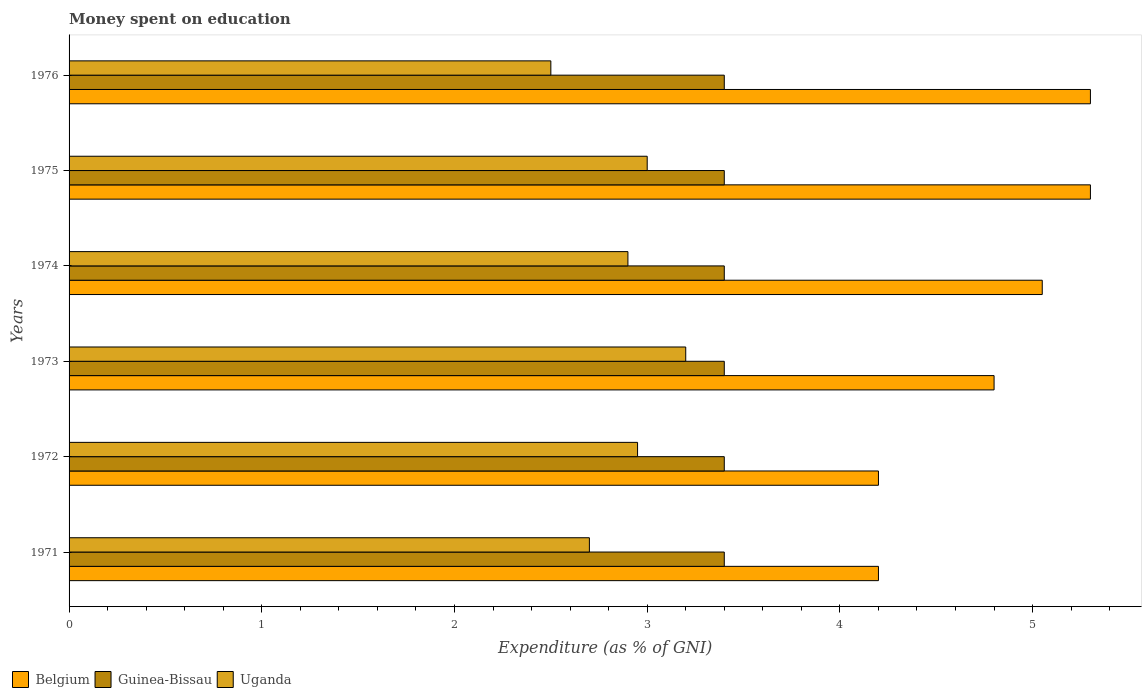How many groups of bars are there?
Your answer should be very brief. 6. Are the number of bars on each tick of the Y-axis equal?
Your response must be concise. Yes. How many bars are there on the 6th tick from the bottom?
Ensure brevity in your answer.  3. What is the label of the 6th group of bars from the top?
Give a very brief answer. 1971. What is the amount of money spent on education in Uganda in 1974?
Your answer should be very brief. 2.9. In which year was the amount of money spent on education in Uganda maximum?
Give a very brief answer. 1973. What is the total amount of money spent on education in Guinea-Bissau in the graph?
Offer a terse response. 20.4. What is the difference between the amount of money spent on education in Belgium in 1971 and that in 1973?
Make the answer very short. -0.6. What is the difference between the amount of money spent on education in Belgium in 1971 and the amount of money spent on education in Uganda in 1973?
Ensure brevity in your answer.  1. What is the average amount of money spent on education in Belgium per year?
Your answer should be very brief. 4.81. In the year 1974, what is the difference between the amount of money spent on education in Guinea-Bissau and amount of money spent on education in Belgium?
Offer a very short reply. -1.65. In how many years, is the amount of money spent on education in Guinea-Bissau greater than 3 %?
Keep it short and to the point. 6. Is the difference between the amount of money spent on education in Guinea-Bissau in 1972 and 1975 greater than the difference between the amount of money spent on education in Belgium in 1972 and 1975?
Offer a very short reply. Yes. What is the difference between the highest and the lowest amount of money spent on education in Belgium?
Ensure brevity in your answer.  1.1. In how many years, is the amount of money spent on education in Guinea-Bissau greater than the average amount of money spent on education in Guinea-Bissau taken over all years?
Keep it short and to the point. 0. Is the sum of the amount of money spent on education in Guinea-Bissau in 1974 and 1975 greater than the maximum amount of money spent on education in Uganda across all years?
Give a very brief answer. Yes. What does the 1st bar from the top in 1976 represents?
Your response must be concise. Uganda. What does the 1st bar from the bottom in 1972 represents?
Your answer should be very brief. Belgium. Are all the bars in the graph horizontal?
Make the answer very short. Yes. What is the difference between two consecutive major ticks on the X-axis?
Provide a succinct answer. 1. Are the values on the major ticks of X-axis written in scientific E-notation?
Your response must be concise. No. How are the legend labels stacked?
Offer a very short reply. Horizontal. What is the title of the graph?
Ensure brevity in your answer.  Money spent on education. What is the label or title of the X-axis?
Provide a succinct answer. Expenditure (as % of GNI). What is the label or title of the Y-axis?
Provide a short and direct response. Years. What is the Expenditure (as % of GNI) of Guinea-Bissau in 1971?
Give a very brief answer. 3.4. What is the Expenditure (as % of GNI) in Belgium in 1972?
Offer a terse response. 4.2. What is the Expenditure (as % of GNI) in Uganda in 1972?
Your response must be concise. 2.95. What is the Expenditure (as % of GNI) in Belgium in 1973?
Make the answer very short. 4.8. What is the Expenditure (as % of GNI) of Uganda in 1973?
Your answer should be very brief. 3.2. What is the Expenditure (as % of GNI) in Belgium in 1974?
Your response must be concise. 5.05. What is the Expenditure (as % of GNI) of Guinea-Bissau in 1974?
Offer a terse response. 3.4. What is the Expenditure (as % of GNI) in Guinea-Bissau in 1975?
Give a very brief answer. 3.4. What is the Expenditure (as % of GNI) of Guinea-Bissau in 1976?
Provide a succinct answer. 3.4. What is the Expenditure (as % of GNI) of Uganda in 1976?
Keep it short and to the point. 2.5. Across all years, what is the maximum Expenditure (as % of GNI) in Belgium?
Ensure brevity in your answer.  5.3. Across all years, what is the minimum Expenditure (as % of GNI) in Uganda?
Provide a succinct answer. 2.5. What is the total Expenditure (as % of GNI) of Belgium in the graph?
Provide a succinct answer. 28.85. What is the total Expenditure (as % of GNI) of Guinea-Bissau in the graph?
Ensure brevity in your answer.  20.4. What is the total Expenditure (as % of GNI) of Uganda in the graph?
Provide a short and direct response. 17.25. What is the difference between the Expenditure (as % of GNI) in Uganda in 1971 and that in 1972?
Make the answer very short. -0.25. What is the difference between the Expenditure (as % of GNI) of Belgium in 1971 and that in 1973?
Provide a short and direct response. -0.6. What is the difference between the Expenditure (as % of GNI) in Belgium in 1971 and that in 1974?
Give a very brief answer. -0.85. What is the difference between the Expenditure (as % of GNI) of Guinea-Bissau in 1971 and that in 1974?
Provide a short and direct response. 0. What is the difference between the Expenditure (as % of GNI) in Belgium in 1971 and that in 1975?
Provide a succinct answer. -1.1. What is the difference between the Expenditure (as % of GNI) of Guinea-Bissau in 1971 and that in 1976?
Offer a very short reply. 0. What is the difference between the Expenditure (as % of GNI) in Uganda in 1971 and that in 1976?
Give a very brief answer. 0.2. What is the difference between the Expenditure (as % of GNI) of Belgium in 1972 and that in 1973?
Keep it short and to the point. -0.6. What is the difference between the Expenditure (as % of GNI) in Uganda in 1972 and that in 1973?
Your answer should be compact. -0.25. What is the difference between the Expenditure (as % of GNI) of Belgium in 1972 and that in 1974?
Make the answer very short. -0.85. What is the difference between the Expenditure (as % of GNI) of Uganda in 1972 and that in 1974?
Provide a short and direct response. 0.05. What is the difference between the Expenditure (as % of GNI) in Belgium in 1972 and that in 1975?
Ensure brevity in your answer.  -1.1. What is the difference between the Expenditure (as % of GNI) of Guinea-Bissau in 1972 and that in 1975?
Offer a terse response. 0. What is the difference between the Expenditure (as % of GNI) in Uganda in 1972 and that in 1975?
Offer a very short reply. -0.05. What is the difference between the Expenditure (as % of GNI) of Guinea-Bissau in 1972 and that in 1976?
Provide a short and direct response. 0. What is the difference between the Expenditure (as % of GNI) of Uganda in 1972 and that in 1976?
Your answer should be very brief. 0.45. What is the difference between the Expenditure (as % of GNI) of Belgium in 1973 and that in 1974?
Provide a short and direct response. -0.25. What is the difference between the Expenditure (as % of GNI) of Uganda in 1973 and that in 1974?
Your answer should be compact. 0.3. What is the difference between the Expenditure (as % of GNI) of Belgium in 1973 and that in 1975?
Your answer should be compact. -0.5. What is the difference between the Expenditure (as % of GNI) of Uganda in 1973 and that in 1975?
Give a very brief answer. 0.2. What is the difference between the Expenditure (as % of GNI) in Guinea-Bissau in 1974 and that in 1975?
Provide a short and direct response. 0. What is the difference between the Expenditure (as % of GNI) of Uganda in 1974 and that in 1975?
Ensure brevity in your answer.  -0.1. What is the difference between the Expenditure (as % of GNI) of Belgium in 1974 and that in 1976?
Ensure brevity in your answer.  -0.25. What is the difference between the Expenditure (as % of GNI) of Guinea-Bissau in 1974 and that in 1976?
Your answer should be compact. 0. What is the difference between the Expenditure (as % of GNI) in Belgium in 1971 and the Expenditure (as % of GNI) in Guinea-Bissau in 1972?
Ensure brevity in your answer.  0.8. What is the difference between the Expenditure (as % of GNI) of Belgium in 1971 and the Expenditure (as % of GNI) of Uganda in 1972?
Provide a succinct answer. 1.25. What is the difference between the Expenditure (as % of GNI) in Guinea-Bissau in 1971 and the Expenditure (as % of GNI) in Uganda in 1972?
Your response must be concise. 0.45. What is the difference between the Expenditure (as % of GNI) of Belgium in 1971 and the Expenditure (as % of GNI) of Guinea-Bissau in 1973?
Ensure brevity in your answer.  0.8. What is the difference between the Expenditure (as % of GNI) of Belgium in 1971 and the Expenditure (as % of GNI) of Guinea-Bissau in 1974?
Your answer should be compact. 0.8. What is the difference between the Expenditure (as % of GNI) of Belgium in 1971 and the Expenditure (as % of GNI) of Uganda in 1974?
Provide a short and direct response. 1.3. What is the difference between the Expenditure (as % of GNI) of Belgium in 1971 and the Expenditure (as % of GNI) of Guinea-Bissau in 1975?
Make the answer very short. 0.8. What is the difference between the Expenditure (as % of GNI) in Belgium in 1971 and the Expenditure (as % of GNI) in Uganda in 1975?
Offer a very short reply. 1.2. What is the difference between the Expenditure (as % of GNI) of Belgium in 1971 and the Expenditure (as % of GNI) of Guinea-Bissau in 1976?
Your answer should be very brief. 0.8. What is the difference between the Expenditure (as % of GNI) in Belgium in 1972 and the Expenditure (as % of GNI) in Guinea-Bissau in 1973?
Give a very brief answer. 0.8. What is the difference between the Expenditure (as % of GNI) of Guinea-Bissau in 1972 and the Expenditure (as % of GNI) of Uganda in 1973?
Offer a very short reply. 0.2. What is the difference between the Expenditure (as % of GNI) of Guinea-Bissau in 1972 and the Expenditure (as % of GNI) of Uganda in 1974?
Ensure brevity in your answer.  0.5. What is the difference between the Expenditure (as % of GNI) in Belgium in 1972 and the Expenditure (as % of GNI) in Guinea-Bissau in 1975?
Offer a terse response. 0.8. What is the difference between the Expenditure (as % of GNI) in Belgium in 1972 and the Expenditure (as % of GNI) in Uganda in 1975?
Your answer should be very brief. 1.2. What is the difference between the Expenditure (as % of GNI) in Guinea-Bissau in 1972 and the Expenditure (as % of GNI) in Uganda in 1975?
Offer a very short reply. 0.4. What is the difference between the Expenditure (as % of GNI) in Belgium in 1972 and the Expenditure (as % of GNI) in Guinea-Bissau in 1976?
Offer a very short reply. 0.8. What is the difference between the Expenditure (as % of GNI) in Belgium in 1973 and the Expenditure (as % of GNI) in Guinea-Bissau in 1974?
Your answer should be very brief. 1.4. What is the difference between the Expenditure (as % of GNI) of Belgium in 1973 and the Expenditure (as % of GNI) of Guinea-Bissau in 1975?
Offer a very short reply. 1.4. What is the difference between the Expenditure (as % of GNI) of Guinea-Bissau in 1973 and the Expenditure (as % of GNI) of Uganda in 1975?
Provide a succinct answer. 0.4. What is the difference between the Expenditure (as % of GNI) of Guinea-Bissau in 1973 and the Expenditure (as % of GNI) of Uganda in 1976?
Ensure brevity in your answer.  0.9. What is the difference between the Expenditure (as % of GNI) in Belgium in 1974 and the Expenditure (as % of GNI) in Guinea-Bissau in 1975?
Give a very brief answer. 1.65. What is the difference between the Expenditure (as % of GNI) in Belgium in 1974 and the Expenditure (as % of GNI) in Uganda in 1975?
Offer a terse response. 2.05. What is the difference between the Expenditure (as % of GNI) of Belgium in 1974 and the Expenditure (as % of GNI) of Guinea-Bissau in 1976?
Your response must be concise. 1.65. What is the difference between the Expenditure (as % of GNI) of Belgium in 1974 and the Expenditure (as % of GNI) of Uganda in 1976?
Your answer should be compact. 2.55. What is the difference between the Expenditure (as % of GNI) in Guinea-Bissau in 1975 and the Expenditure (as % of GNI) in Uganda in 1976?
Provide a succinct answer. 0.9. What is the average Expenditure (as % of GNI) of Belgium per year?
Offer a very short reply. 4.81. What is the average Expenditure (as % of GNI) of Guinea-Bissau per year?
Give a very brief answer. 3.4. What is the average Expenditure (as % of GNI) in Uganda per year?
Keep it short and to the point. 2.88. In the year 1972, what is the difference between the Expenditure (as % of GNI) in Belgium and Expenditure (as % of GNI) in Guinea-Bissau?
Your answer should be very brief. 0.8. In the year 1972, what is the difference between the Expenditure (as % of GNI) in Belgium and Expenditure (as % of GNI) in Uganda?
Keep it short and to the point. 1.25. In the year 1972, what is the difference between the Expenditure (as % of GNI) in Guinea-Bissau and Expenditure (as % of GNI) in Uganda?
Make the answer very short. 0.45. In the year 1974, what is the difference between the Expenditure (as % of GNI) of Belgium and Expenditure (as % of GNI) of Guinea-Bissau?
Give a very brief answer. 1.65. In the year 1974, what is the difference between the Expenditure (as % of GNI) of Belgium and Expenditure (as % of GNI) of Uganda?
Offer a very short reply. 2.15. In the year 1974, what is the difference between the Expenditure (as % of GNI) in Guinea-Bissau and Expenditure (as % of GNI) in Uganda?
Offer a terse response. 0.5. In the year 1975, what is the difference between the Expenditure (as % of GNI) of Guinea-Bissau and Expenditure (as % of GNI) of Uganda?
Your answer should be very brief. 0.4. What is the ratio of the Expenditure (as % of GNI) in Belgium in 1971 to that in 1972?
Provide a short and direct response. 1. What is the ratio of the Expenditure (as % of GNI) of Guinea-Bissau in 1971 to that in 1972?
Offer a very short reply. 1. What is the ratio of the Expenditure (as % of GNI) in Uganda in 1971 to that in 1972?
Ensure brevity in your answer.  0.92. What is the ratio of the Expenditure (as % of GNI) in Belgium in 1971 to that in 1973?
Make the answer very short. 0.88. What is the ratio of the Expenditure (as % of GNI) of Guinea-Bissau in 1971 to that in 1973?
Offer a terse response. 1. What is the ratio of the Expenditure (as % of GNI) of Uganda in 1971 to that in 1973?
Ensure brevity in your answer.  0.84. What is the ratio of the Expenditure (as % of GNI) in Belgium in 1971 to that in 1974?
Your answer should be compact. 0.83. What is the ratio of the Expenditure (as % of GNI) of Guinea-Bissau in 1971 to that in 1974?
Your answer should be compact. 1. What is the ratio of the Expenditure (as % of GNI) in Belgium in 1971 to that in 1975?
Your response must be concise. 0.79. What is the ratio of the Expenditure (as % of GNI) of Uganda in 1971 to that in 1975?
Your response must be concise. 0.9. What is the ratio of the Expenditure (as % of GNI) in Belgium in 1971 to that in 1976?
Give a very brief answer. 0.79. What is the ratio of the Expenditure (as % of GNI) of Guinea-Bissau in 1971 to that in 1976?
Your response must be concise. 1. What is the ratio of the Expenditure (as % of GNI) of Uganda in 1971 to that in 1976?
Provide a succinct answer. 1.08. What is the ratio of the Expenditure (as % of GNI) of Belgium in 1972 to that in 1973?
Provide a succinct answer. 0.88. What is the ratio of the Expenditure (as % of GNI) in Guinea-Bissau in 1972 to that in 1973?
Keep it short and to the point. 1. What is the ratio of the Expenditure (as % of GNI) of Uganda in 1972 to that in 1973?
Ensure brevity in your answer.  0.92. What is the ratio of the Expenditure (as % of GNI) of Belgium in 1972 to that in 1974?
Your answer should be compact. 0.83. What is the ratio of the Expenditure (as % of GNI) in Uganda in 1972 to that in 1974?
Provide a short and direct response. 1.02. What is the ratio of the Expenditure (as % of GNI) of Belgium in 1972 to that in 1975?
Ensure brevity in your answer.  0.79. What is the ratio of the Expenditure (as % of GNI) in Uganda in 1972 to that in 1975?
Keep it short and to the point. 0.98. What is the ratio of the Expenditure (as % of GNI) in Belgium in 1972 to that in 1976?
Give a very brief answer. 0.79. What is the ratio of the Expenditure (as % of GNI) in Guinea-Bissau in 1972 to that in 1976?
Offer a terse response. 1. What is the ratio of the Expenditure (as % of GNI) of Uganda in 1972 to that in 1976?
Provide a short and direct response. 1.18. What is the ratio of the Expenditure (as % of GNI) in Belgium in 1973 to that in 1974?
Offer a terse response. 0.95. What is the ratio of the Expenditure (as % of GNI) of Uganda in 1973 to that in 1974?
Provide a succinct answer. 1.1. What is the ratio of the Expenditure (as % of GNI) of Belgium in 1973 to that in 1975?
Offer a very short reply. 0.91. What is the ratio of the Expenditure (as % of GNI) of Guinea-Bissau in 1973 to that in 1975?
Ensure brevity in your answer.  1. What is the ratio of the Expenditure (as % of GNI) in Uganda in 1973 to that in 1975?
Ensure brevity in your answer.  1.07. What is the ratio of the Expenditure (as % of GNI) of Belgium in 1973 to that in 1976?
Your answer should be compact. 0.91. What is the ratio of the Expenditure (as % of GNI) in Guinea-Bissau in 1973 to that in 1976?
Offer a very short reply. 1. What is the ratio of the Expenditure (as % of GNI) in Uganda in 1973 to that in 1976?
Offer a terse response. 1.28. What is the ratio of the Expenditure (as % of GNI) of Belgium in 1974 to that in 1975?
Provide a succinct answer. 0.95. What is the ratio of the Expenditure (as % of GNI) in Guinea-Bissau in 1974 to that in 1975?
Offer a very short reply. 1. What is the ratio of the Expenditure (as % of GNI) of Uganda in 1974 to that in 1975?
Offer a very short reply. 0.97. What is the ratio of the Expenditure (as % of GNI) of Belgium in 1974 to that in 1976?
Provide a succinct answer. 0.95. What is the ratio of the Expenditure (as % of GNI) in Guinea-Bissau in 1974 to that in 1976?
Keep it short and to the point. 1. What is the ratio of the Expenditure (as % of GNI) of Uganda in 1974 to that in 1976?
Offer a terse response. 1.16. What is the ratio of the Expenditure (as % of GNI) in Guinea-Bissau in 1975 to that in 1976?
Offer a very short reply. 1. What is the ratio of the Expenditure (as % of GNI) of Uganda in 1975 to that in 1976?
Provide a short and direct response. 1.2. What is the difference between the highest and the second highest Expenditure (as % of GNI) in Belgium?
Your response must be concise. 0. What is the difference between the highest and the lowest Expenditure (as % of GNI) in Belgium?
Offer a very short reply. 1.1. What is the difference between the highest and the lowest Expenditure (as % of GNI) of Guinea-Bissau?
Offer a very short reply. 0. 